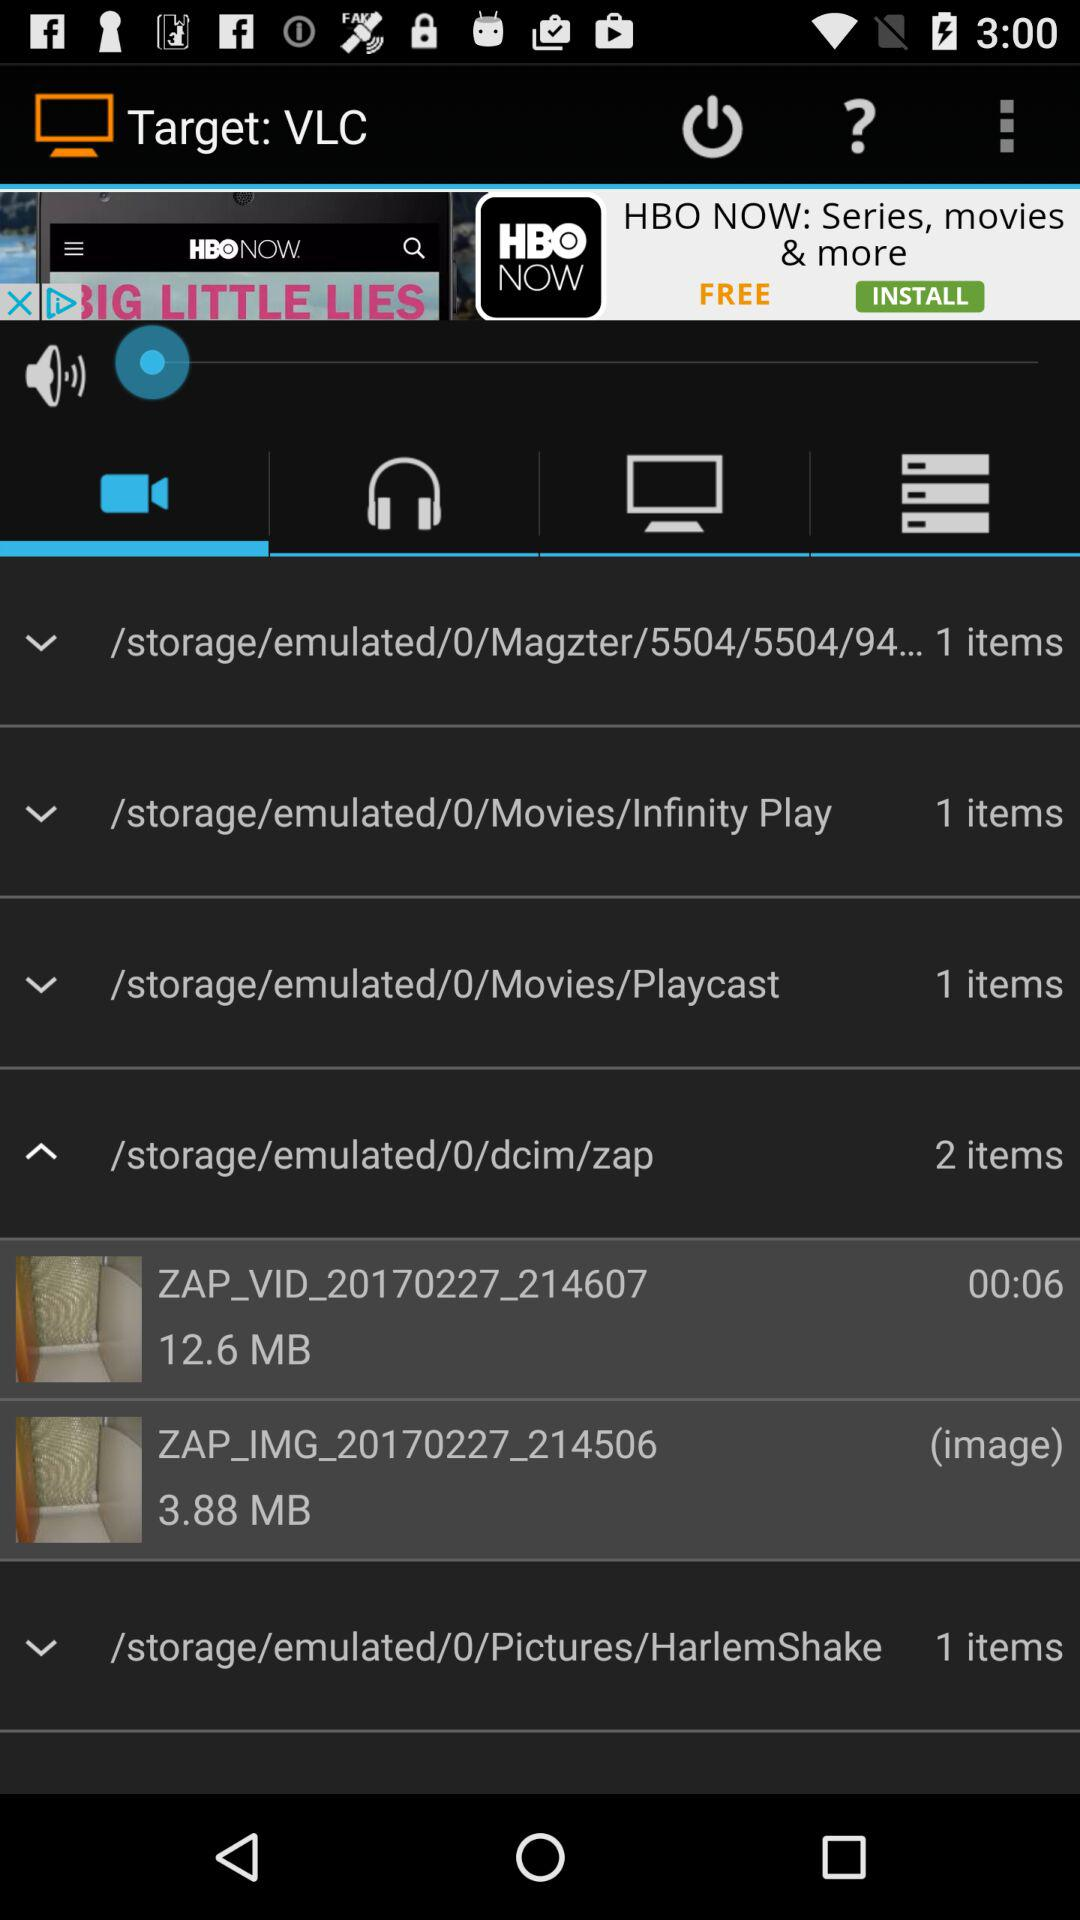Which tab is selected? The selected tab is "Videos". 